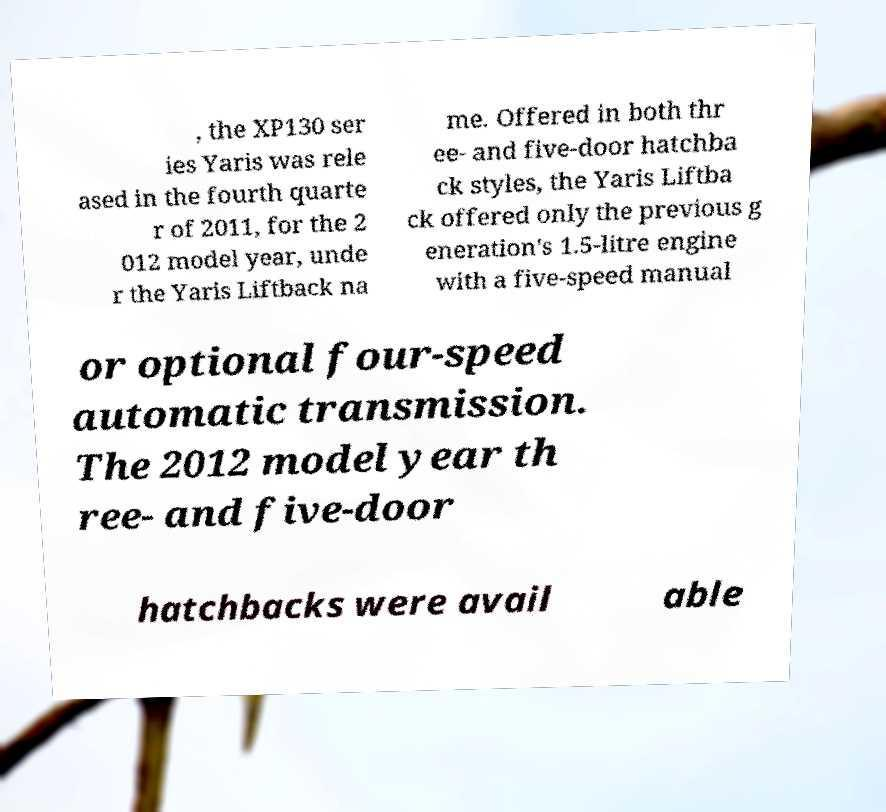For documentation purposes, I need the text within this image transcribed. Could you provide that? , the XP130 ser ies Yaris was rele ased in the fourth quarte r of 2011, for the 2 012 model year, unde r the Yaris Liftback na me. Offered in both thr ee- and five-door hatchba ck styles, the Yaris Liftba ck offered only the previous g eneration's 1.5-litre engine with a five-speed manual or optional four-speed automatic transmission. The 2012 model year th ree- and five-door hatchbacks were avail able 